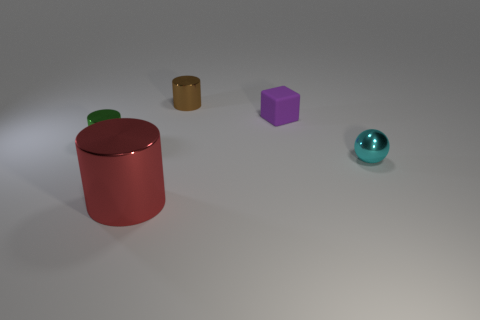What number of purple cubes are in front of the large red cylinder?
Make the answer very short. 0. Are there the same number of cyan balls in front of the small purple object and yellow matte objects?
Keep it short and to the point. No. Are the red thing and the tiny purple cube made of the same material?
Offer a terse response. No. There is a thing that is both left of the cyan thing and to the right of the small brown metallic cylinder; what size is it?
Your response must be concise. Small. How many brown cylinders have the same size as the green metal cylinder?
Keep it short and to the point. 1. There is a cylinder that is in front of the tiny cylinder in front of the tiny brown cylinder; what size is it?
Your answer should be very brief. Large. There is a thing in front of the small cyan shiny thing; is its shape the same as the thing that is on the right side of the tiny purple block?
Your answer should be compact. No. What color is the metallic cylinder that is both right of the tiny green thing and in front of the rubber object?
Ensure brevity in your answer.  Red. Is there another thing that has the same color as the large object?
Offer a terse response. No. The metallic object that is in front of the cyan thing is what color?
Your answer should be compact. Red. 